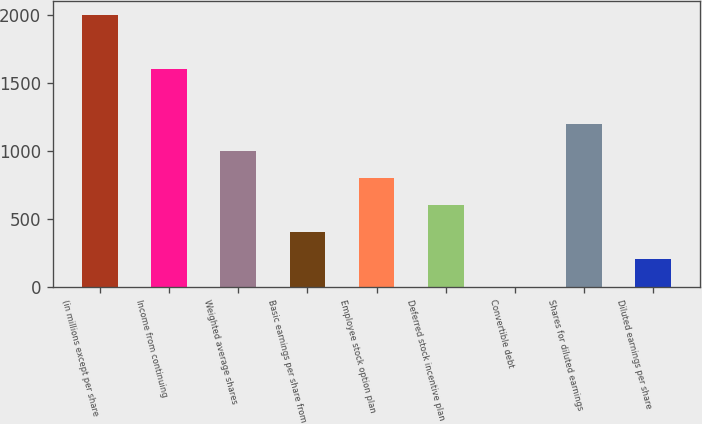Convert chart. <chart><loc_0><loc_0><loc_500><loc_500><bar_chart><fcel>(in millions except per share<fcel>Income from continuing<fcel>Weighted average shares<fcel>Basic earnings per share from<fcel>Employee stock option plan<fcel>Deferred stock incentive plan<fcel>Convertible debt<fcel>Shares for diluted earnings<fcel>Diluted earnings per share<nl><fcel>2003<fcel>1602.58<fcel>1001.95<fcel>401.32<fcel>801.74<fcel>601.53<fcel>0.9<fcel>1202.16<fcel>201.11<nl></chart> 